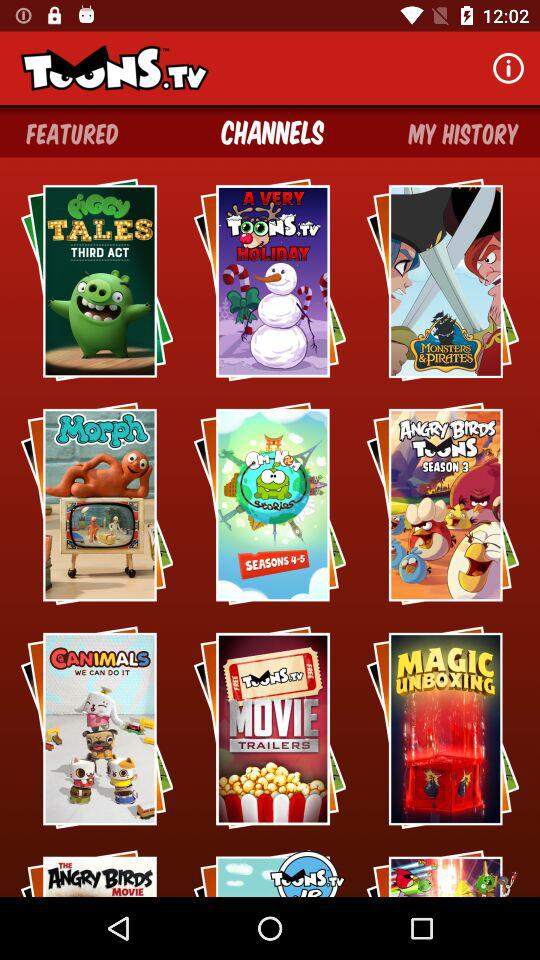Which are the featured toons?
When the provided information is insufficient, respond with <no answer>. <no answer> 